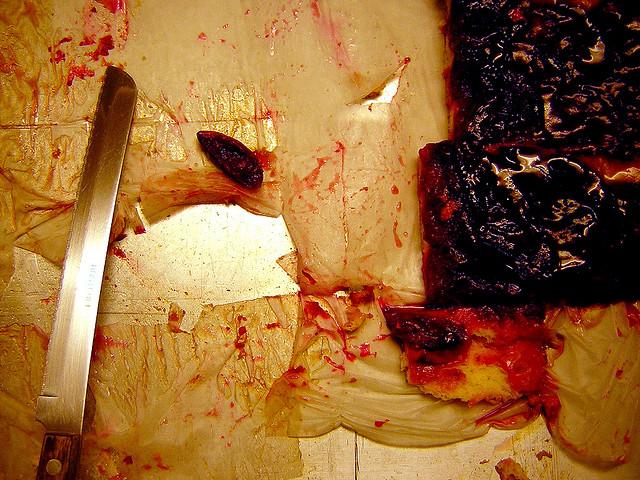What is the handle of the knife made of?
Give a very brief answer. Wood. Where is a serrated blade?
Answer briefly. Left. Is there blood in this image?
Write a very short answer. Yes. 